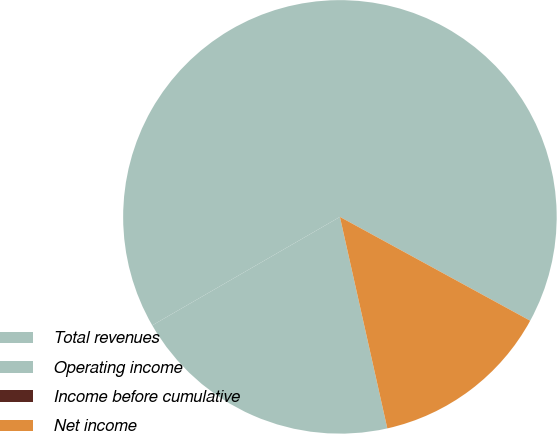<chart> <loc_0><loc_0><loc_500><loc_500><pie_chart><fcel>Total revenues<fcel>Operating income<fcel>Income before cumulative<fcel>Net income<nl><fcel>66.29%<fcel>20.17%<fcel>0.0%<fcel>13.54%<nl></chart> 